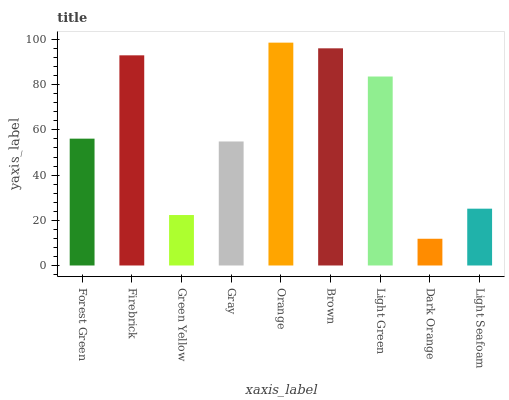Is Dark Orange the minimum?
Answer yes or no. Yes. Is Orange the maximum?
Answer yes or no. Yes. Is Firebrick the minimum?
Answer yes or no. No. Is Firebrick the maximum?
Answer yes or no. No. Is Firebrick greater than Forest Green?
Answer yes or no. Yes. Is Forest Green less than Firebrick?
Answer yes or no. Yes. Is Forest Green greater than Firebrick?
Answer yes or no. No. Is Firebrick less than Forest Green?
Answer yes or no. No. Is Forest Green the high median?
Answer yes or no. Yes. Is Forest Green the low median?
Answer yes or no. Yes. Is Gray the high median?
Answer yes or no. No. Is Orange the low median?
Answer yes or no. No. 